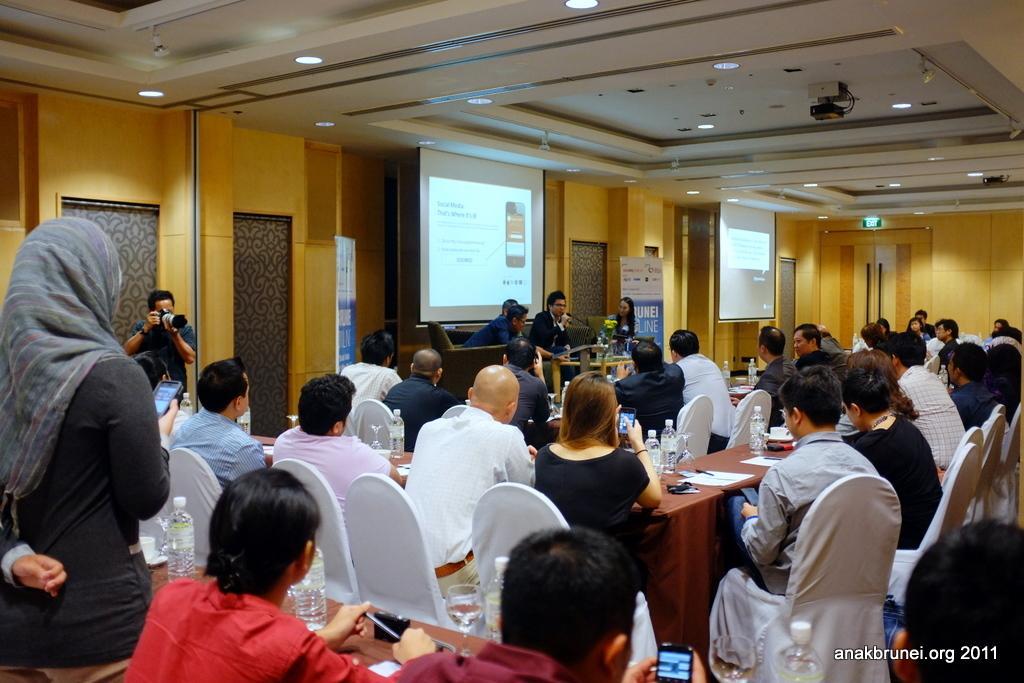Describe this image in one or two sentences. In this picture we can see a some people are sitting on chairs and two people are standing. A man is holding a camera and two other people holding the mobiles. In front of the people there are tables which are covered with clothes. On the tables there are bottles, cups, saucers, papers and some objects. Behind the people there is a banner, projector screens and a wooden wall. At the top there are ceiling lights and a projector. On the image there is a watermark. 